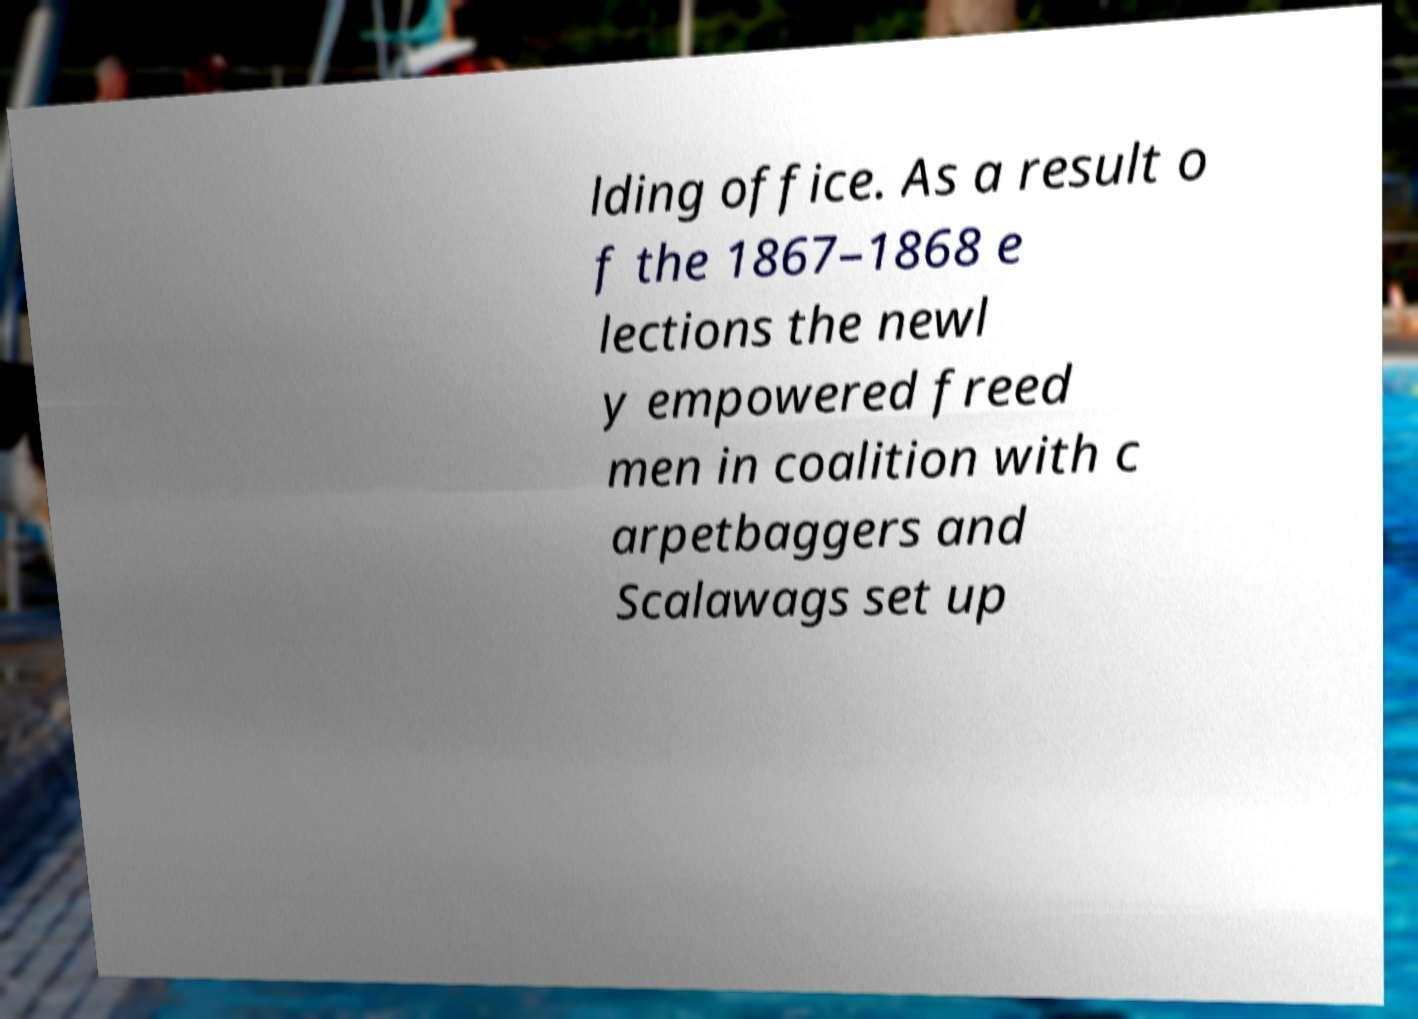Please identify and transcribe the text found in this image. lding office. As a result o f the 1867–1868 e lections the newl y empowered freed men in coalition with c arpetbaggers and Scalawags set up 